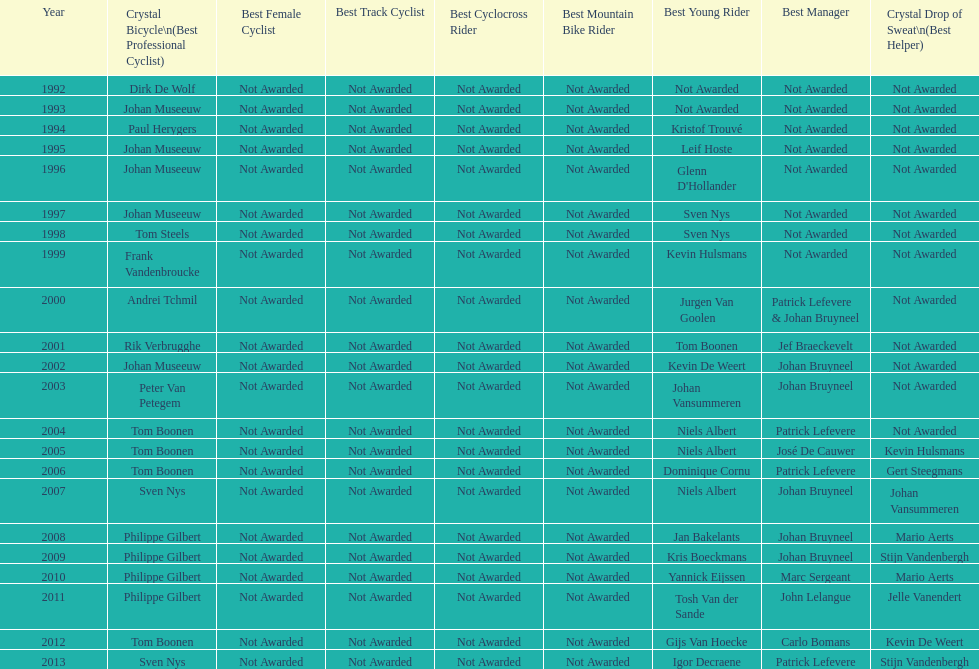Who won the most consecutive crystal bicycles? Philippe Gilbert. 